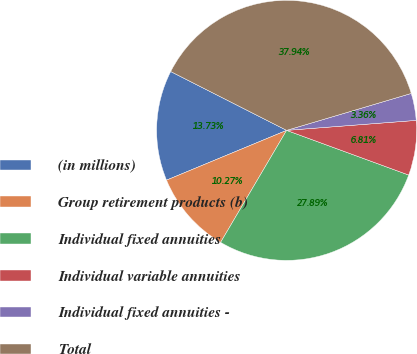Convert chart. <chart><loc_0><loc_0><loc_500><loc_500><pie_chart><fcel>(in millions)<fcel>Group retirement products (b)<fcel>Individual fixed annuities<fcel>Individual variable annuities<fcel>Individual fixed annuities -<fcel>Total<nl><fcel>13.73%<fcel>10.27%<fcel>27.89%<fcel>6.81%<fcel>3.36%<fcel>37.94%<nl></chart> 